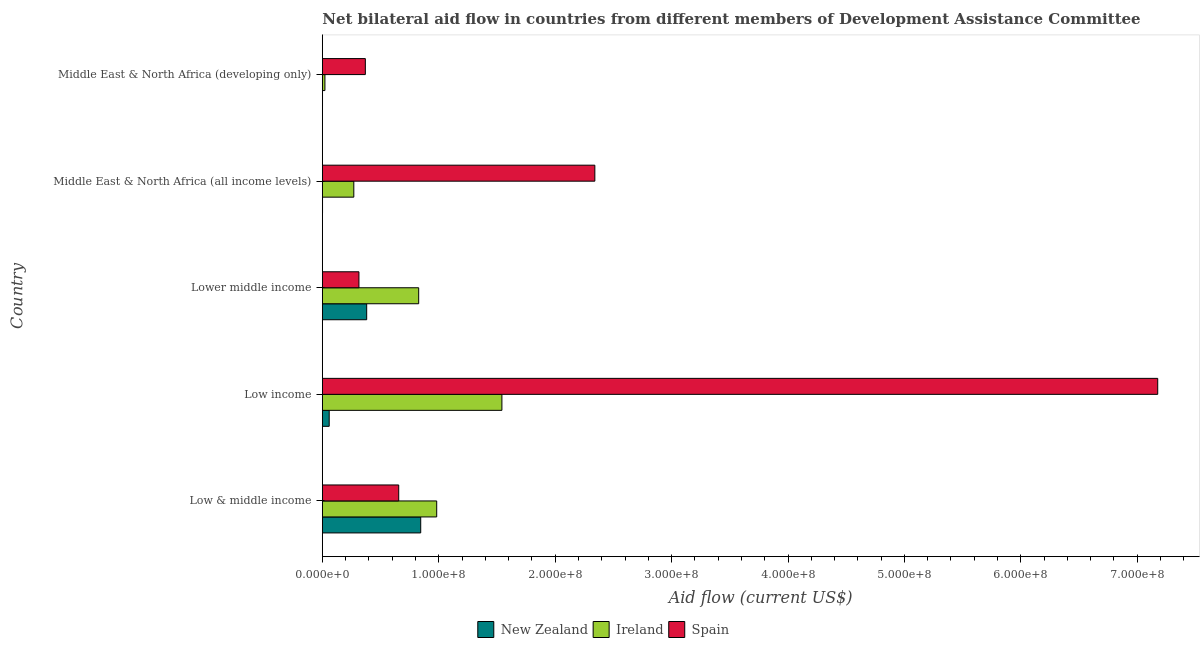How many groups of bars are there?
Your response must be concise. 5. Are the number of bars per tick equal to the number of legend labels?
Provide a short and direct response. Yes. Are the number of bars on each tick of the Y-axis equal?
Offer a terse response. Yes. What is the label of the 5th group of bars from the top?
Offer a very short reply. Low & middle income. In how many cases, is the number of bars for a given country not equal to the number of legend labels?
Offer a very short reply. 0. What is the amount of aid provided by ireland in Middle East & North Africa (developing only)?
Keep it short and to the point. 2.23e+06. Across all countries, what is the maximum amount of aid provided by new zealand?
Offer a terse response. 8.45e+07. Across all countries, what is the minimum amount of aid provided by new zealand?
Ensure brevity in your answer.  1.60e+05. In which country was the amount of aid provided by spain minimum?
Your response must be concise. Lower middle income. What is the total amount of aid provided by new zealand in the graph?
Provide a succinct answer. 1.29e+08. What is the difference between the amount of aid provided by ireland in Low income and that in Middle East & North Africa (developing only)?
Provide a short and direct response. 1.52e+08. What is the difference between the amount of aid provided by spain in Low & middle income and the amount of aid provided by new zealand in Low income?
Provide a succinct answer. 5.97e+07. What is the average amount of aid provided by ireland per country?
Ensure brevity in your answer.  7.29e+07. What is the difference between the amount of aid provided by new zealand and amount of aid provided by spain in Middle East & North Africa (all income levels)?
Offer a very short reply. -2.34e+08. What is the ratio of the amount of aid provided by spain in Lower middle income to that in Middle East & North Africa (developing only)?
Keep it short and to the point. 0.85. Is the amount of aid provided by new zealand in Low & middle income less than that in Lower middle income?
Your answer should be compact. No. Is the difference between the amount of aid provided by new zealand in Low income and Middle East & North Africa (developing only) greater than the difference between the amount of aid provided by spain in Low income and Middle East & North Africa (developing only)?
Ensure brevity in your answer.  No. What is the difference between the highest and the second highest amount of aid provided by new zealand?
Your answer should be very brief. 4.64e+07. What is the difference between the highest and the lowest amount of aid provided by spain?
Provide a succinct answer. 6.86e+08. Is the sum of the amount of aid provided by spain in Low income and Middle East & North Africa (all income levels) greater than the maximum amount of aid provided by ireland across all countries?
Provide a short and direct response. Yes. What does the 1st bar from the top in Middle East & North Africa (developing only) represents?
Your response must be concise. Spain. What does the 1st bar from the bottom in Middle East & North Africa (all income levels) represents?
Make the answer very short. New Zealand. Are all the bars in the graph horizontal?
Your answer should be very brief. Yes. Does the graph contain any zero values?
Give a very brief answer. No. Does the graph contain grids?
Make the answer very short. No. How many legend labels are there?
Make the answer very short. 3. How are the legend labels stacked?
Your response must be concise. Horizontal. What is the title of the graph?
Make the answer very short. Net bilateral aid flow in countries from different members of Development Assistance Committee. Does "Social insurance" appear as one of the legend labels in the graph?
Your response must be concise. No. What is the label or title of the Y-axis?
Your response must be concise. Country. What is the Aid flow (current US$) in New Zealand in Low & middle income?
Your response must be concise. 8.45e+07. What is the Aid flow (current US$) of Ireland in Low & middle income?
Offer a very short reply. 9.82e+07. What is the Aid flow (current US$) in Spain in Low & middle income?
Offer a very short reply. 6.56e+07. What is the Aid flow (current US$) in New Zealand in Low income?
Provide a short and direct response. 5.90e+06. What is the Aid flow (current US$) in Ireland in Low income?
Provide a succinct answer. 1.54e+08. What is the Aid flow (current US$) of Spain in Low income?
Your response must be concise. 7.18e+08. What is the Aid flow (current US$) of New Zealand in Lower middle income?
Provide a short and direct response. 3.81e+07. What is the Aid flow (current US$) of Ireland in Lower middle income?
Ensure brevity in your answer.  8.28e+07. What is the Aid flow (current US$) of Spain in Lower middle income?
Your response must be concise. 3.14e+07. What is the Aid flow (current US$) of New Zealand in Middle East & North Africa (all income levels)?
Keep it short and to the point. 1.80e+05. What is the Aid flow (current US$) of Ireland in Middle East & North Africa (all income levels)?
Your answer should be compact. 2.70e+07. What is the Aid flow (current US$) in Spain in Middle East & North Africa (all income levels)?
Provide a succinct answer. 2.34e+08. What is the Aid flow (current US$) of Ireland in Middle East & North Africa (developing only)?
Provide a short and direct response. 2.23e+06. What is the Aid flow (current US$) in Spain in Middle East & North Africa (developing only)?
Ensure brevity in your answer.  3.70e+07. Across all countries, what is the maximum Aid flow (current US$) in New Zealand?
Your answer should be very brief. 8.45e+07. Across all countries, what is the maximum Aid flow (current US$) in Ireland?
Ensure brevity in your answer.  1.54e+08. Across all countries, what is the maximum Aid flow (current US$) in Spain?
Your answer should be very brief. 7.18e+08. Across all countries, what is the minimum Aid flow (current US$) of Ireland?
Ensure brevity in your answer.  2.23e+06. Across all countries, what is the minimum Aid flow (current US$) of Spain?
Provide a short and direct response. 3.14e+07. What is the total Aid flow (current US$) in New Zealand in the graph?
Make the answer very short. 1.29e+08. What is the total Aid flow (current US$) of Ireland in the graph?
Offer a terse response. 3.65e+08. What is the total Aid flow (current US$) of Spain in the graph?
Make the answer very short. 1.09e+09. What is the difference between the Aid flow (current US$) of New Zealand in Low & middle income and that in Low income?
Offer a very short reply. 7.86e+07. What is the difference between the Aid flow (current US$) of Ireland in Low & middle income and that in Low income?
Provide a succinct answer. -5.60e+07. What is the difference between the Aid flow (current US$) of Spain in Low & middle income and that in Low income?
Your answer should be compact. -6.52e+08. What is the difference between the Aid flow (current US$) in New Zealand in Low & middle income and that in Lower middle income?
Your answer should be compact. 4.64e+07. What is the difference between the Aid flow (current US$) in Ireland in Low & middle income and that in Lower middle income?
Provide a succinct answer. 1.55e+07. What is the difference between the Aid flow (current US$) in Spain in Low & middle income and that in Lower middle income?
Your response must be concise. 3.42e+07. What is the difference between the Aid flow (current US$) of New Zealand in Low & middle income and that in Middle East & North Africa (all income levels)?
Give a very brief answer. 8.43e+07. What is the difference between the Aid flow (current US$) in Ireland in Low & middle income and that in Middle East & North Africa (all income levels)?
Keep it short and to the point. 7.12e+07. What is the difference between the Aid flow (current US$) of Spain in Low & middle income and that in Middle East & North Africa (all income levels)?
Offer a very short reply. -1.68e+08. What is the difference between the Aid flow (current US$) in New Zealand in Low & middle income and that in Middle East & North Africa (developing only)?
Make the answer very short. 8.44e+07. What is the difference between the Aid flow (current US$) of Ireland in Low & middle income and that in Middle East & North Africa (developing only)?
Give a very brief answer. 9.60e+07. What is the difference between the Aid flow (current US$) of Spain in Low & middle income and that in Middle East & North Africa (developing only)?
Provide a succinct answer. 2.87e+07. What is the difference between the Aid flow (current US$) of New Zealand in Low income and that in Lower middle income?
Your response must be concise. -3.22e+07. What is the difference between the Aid flow (current US$) of Ireland in Low income and that in Lower middle income?
Offer a very short reply. 7.15e+07. What is the difference between the Aid flow (current US$) in Spain in Low income and that in Lower middle income?
Make the answer very short. 6.86e+08. What is the difference between the Aid flow (current US$) of New Zealand in Low income and that in Middle East & North Africa (all income levels)?
Your answer should be very brief. 5.72e+06. What is the difference between the Aid flow (current US$) in Ireland in Low income and that in Middle East & North Africa (all income levels)?
Provide a succinct answer. 1.27e+08. What is the difference between the Aid flow (current US$) of Spain in Low income and that in Middle East & North Africa (all income levels)?
Keep it short and to the point. 4.84e+08. What is the difference between the Aid flow (current US$) of New Zealand in Low income and that in Middle East & North Africa (developing only)?
Provide a short and direct response. 5.74e+06. What is the difference between the Aid flow (current US$) of Ireland in Low income and that in Middle East & North Africa (developing only)?
Offer a terse response. 1.52e+08. What is the difference between the Aid flow (current US$) of Spain in Low income and that in Middle East & North Africa (developing only)?
Provide a succinct answer. 6.81e+08. What is the difference between the Aid flow (current US$) of New Zealand in Lower middle income and that in Middle East & North Africa (all income levels)?
Make the answer very short. 3.79e+07. What is the difference between the Aid flow (current US$) in Ireland in Lower middle income and that in Middle East & North Africa (all income levels)?
Offer a terse response. 5.57e+07. What is the difference between the Aid flow (current US$) of Spain in Lower middle income and that in Middle East & North Africa (all income levels)?
Your answer should be very brief. -2.03e+08. What is the difference between the Aid flow (current US$) of New Zealand in Lower middle income and that in Middle East & North Africa (developing only)?
Ensure brevity in your answer.  3.79e+07. What is the difference between the Aid flow (current US$) of Ireland in Lower middle income and that in Middle East & North Africa (developing only)?
Provide a succinct answer. 8.05e+07. What is the difference between the Aid flow (current US$) in Spain in Lower middle income and that in Middle East & North Africa (developing only)?
Ensure brevity in your answer.  -5.50e+06. What is the difference between the Aid flow (current US$) in Ireland in Middle East & North Africa (all income levels) and that in Middle East & North Africa (developing only)?
Make the answer very short. 2.48e+07. What is the difference between the Aid flow (current US$) in Spain in Middle East & North Africa (all income levels) and that in Middle East & North Africa (developing only)?
Make the answer very short. 1.97e+08. What is the difference between the Aid flow (current US$) in New Zealand in Low & middle income and the Aid flow (current US$) in Ireland in Low income?
Provide a succinct answer. -6.97e+07. What is the difference between the Aid flow (current US$) of New Zealand in Low & middle income and the Aid flow (current US$) of Spain in Low income?
Your answer should be very brief. -6.33e+08. What is the difference between the Aid flow (current US$) in Ireland in Low & middle income and the Aid flow (current US$) in Spain in Low income?
Offer a terse response. -6.19e+08. What is the difference between the Aid flow (current US$) in New Zealand in Low & middle income and the Aid flow (current US$) in Ireland in Lower middle income?
Your answer should be compact. 1.74e+06. What is the difference between the Aid flow (current US$) of New Zealand in Low & middle income and the Aid flow (current US$) of Spain in Lower middle income?
Offer a very short reply. 5.31e+07. What is the difference between the Aid flow (current US$) of Ireland in Low & middle income and the Aid flow (current US$) of Spain in Lower middle income?
Your response must be concise. 6.68e+07. What is the difference between the Aid flow (current US$) in New Zealand in Low & middle income and the Aid flow (current US$) in Ireland in Middle East & North Africa (all income levels)?
Offer a terse response. 5.75e+07. What is the difference between the Aid flow (current US$) in New Zealand in Low & middle income and the Aid flow (current US$) in Spain in Middle East & North Africa (all income levels)?
Ensure brevity in your answer.  -1.50e+08. What is the difference between the Aid flow (current US$) of Ireland in Low & middle income and the Aid flow (current US$) of Spain in Middle East & North Africa (all income levels)?
Give a very brief answer. -1.36e+08. What is the difference between the Aid flow (current US$) in New Zealand in Low & middle income and the Aid flow (current US$) in Ireland in Middle East & North Africa (developing only)?
Provide a succinct answer. 8.23e+07. What is the difference between the Aid flow (current US$) of New Zealand in Low & middle income and the Aid flow (current US$) of Spain in Middle East & North Africa (developing only)?
Your answer should be very brief. 4.76e+07. What is the difference between the Aid flow (current US$) of Ireland in Low & middle income and the Aid flow (current US$) of Spain in Middle East & North Africa (developing only)?
Offer a very short reply. 6.13e+07. What is the difference between the Aid flow (current US$) in New Zealand in Low income and the Aid flow (current US$) in Ireland in Lower middle income?
Offer a terse response. -7.69e+07. What is the difference between the Aid flow (current US$) in New Zealand in Low income and the Aid flow (current US$) in Spain in Lower middle income?
Keep it short and to the point. -2.56e+07. What is the difference between the Aid flow (current US$) in Ireland in Low income and the Aid flow (current US$) in Spain in Lower middle income?
Provide a short and direct response. 1.23e+08. What is the difference between the Aid flow (current US$) of New Zealand in Low income and the Aid flow (current US$) of Ireland in Middle East & North Africa (all income levels)?
Give a very brief answer. -2.11e+07. What is the difference between the Aid flow (current US$) in New Zealand in Low income and the Aid flow (current US$) in Spain in Middle East & North Africa (all income levels)?
Your response must be concise. -2.28e+08. What is the difference between the Aid flow (current US$) in Ireland in Low income and the Aid flow (current US$) in Spain in Middle East & North Africa (all income levels)?
Your response must be concise. -7.98e+07. What is the difference between the Aid flow (current US$) of New Zealand in Low income and the Aid flow (current US$) of Ireland in Middle East & North Africa (developing only)?
Give a very brief answer. 3.67e+06. What is the difference between the Aid flow (current US$) in New Zealand in Low income and the Aid flow (current US$) in Spain in Middle East & North Africa (developing only)?
Provide a succinct answer. -3.10e+07. What is the difference between the Aid flow (current US$) of Ireland in Low income and the Aid flow (current US$) of Spain in Middle East & North Africa (developing only)?
Offer a very short reply. 1.17e+08. What is the difference between the Aid flow (current US$) in New Zealand in Lower middle income and the Aid flow (current US$) in Ireland in Middle East & North Africa (all income levels)?
Make the answer very short. 1.11e+07. What is the difference between the Aid flow (current US$) in New Zealand in Lower middle income and the Aid flow (current US$) in Spain in Middle East & North Africa (all income levels)?
Your response must be concise. -1.96e+08. What is the difference between the Aid flow (current US$) of Ireland in Lower middle income and the Aid flow (current US$) of Spain in Middle East & North Africa (all income levels)?
Make the answer very short. -1.51e+08. What is the difference between the Aid flow (current US$) in New Zealand in Lower middle income and the Aid flow (current US$) in Ireland in Middle East & North Africa (developing only)?
Give a very brief answer. 3.59e+07. What is the difference between the Aid flow (current US$) in New Zealand in Lower middle income and the Aid flow (current US$) in Spain in Middle East & North Africa (developing only)?
Your answer should be very brief. 1.15e+06. What is the difference between the Aid flow (current US$) in Ireland in Lower middle income and the Aid flow (current US$) in Spain in Middle East & North Africa (developing only)?
Your response must be concise. 4.58e+07. What is the difference between the Aid flow (current US$) in New Zealand in Middle East & North Africa (all income levels) and the Aid flow (current US$) in Ireland in Middle East & North Africa (developing only)?
Your response must be concise. -2.05e+06. What is the difference between the Aid flow (current US$) in New Zealand in Middle East & North Africa (all income levels) and the Aid flow (current US$) in Spain in Middle East & North Africa (developing only)?
Offer a terse response. -3.68e+07. What is the difference between the Aid flow (current US$) in Ireland in Middle East & North Africa (all income levels) and the Aid flow (current US$) in Spain in Middle East & North Africa (developing only)?
Your answer should be compact. -9.91e+06. What is the average Aid flow (current US$) in New Zealand per country?
Ensure brevity in your answer.  2.58e+07. What is the average Aid flow (current US$) in Ireland per country?
Ensure brevity in your answer.  7.29e+07. What is the average Aid flow (current US$) of Spain per country?
Give a very brief answer. 2.17e+08. What is the difference between the Aid flow (current US$) in New Zealand and Aid flow (current US$) in Ireland in Low & middle income?
Offer a terse response. -1.37e+07. What is the difference between the Aid flow (current US$) of New Zealand and Aid flow (current US$) of Spain in Low & middle income?
Your answer should be compact. 1.89e+07. What is the difference between the Aid flow (current US$) of Ireland and Aid flow (current US$) of Spain in Low & middle income?
Your answer should be compact. 3.26e+07. What is the difference between the Aid flow (current US$) of New Zealand and Aid flow (current US$) of Ireland in Low income?
Offer a terse response. -1.48e+08. What is the difference between the Aid flow (current US$) of New Zealand and Aid flow (current US$) of Spain in Low income?
Keep it short and to the point. -7.12e+08. What is the difference between the Aid flow (current US$) of Ireland and Aid flow (current US$) of Spain in Low income?
Keep it short and to the point. -5.63e+08. What is the difference between the Aid flow (current US$) in New Zealand and Aid flow (current US$) in Ireland in Lower middle income?
Offer a very short reply. -4.47e+07. What is the difference between the Aid flow (current US$) in New Zealand and Aid flow (current US$) in Spain in Lower middle income?
Give a very brief answer. 6.65e+06. What is the difference between the Aid flow (current US$) of Ireland and Aid flow (current US$) of Spain in Lower middle income?
Make the answer very short. 5.13e+07. What is the difference between the Aid flow (current US$) of New Zealand and Aid flow (current US$) of Ireland in Middle East & North Africa (all income levels)?
Offer a very short reply. -2.69e+07. What is the difference between the Aid flow (current US$) in New Zealand and Aid flow (current US$) in Spain in Middle East & North Africa (all income levels)?
Your answer should be compact. -2.34e+08. What is the difference between the Aid flow (current US$) in Ireland and Aid flow (current US$) in Spain in Middle East & North Africa (all income levels)?
Your answer should be compact. -2.07e+08. What is the difference between the Aid flow (current US$) of New Zealand and Aid flow (current US$) of Ireland in Middle East & North Africa (developing only)?
Give a very brief answer. -2.07e+06. What is the difference between the Aid flow (current US$) of New Zealand and Aid flow (current US$) of Spain in Middle East & North Africa (developing only)?
Ensure brevity in your answer.  -3.68e+07. What is the difference between the Aid flow (current US$) of Ireland and Aid flow (current US$) of Spain in Middle East & North Africa (developing only)?
Offer a terse response. -3.47e+07. What is the ratio of the Aid flow (current US$) in New Zealand in Low & middle income to that in Low income?
Offer a terse response. 14.32. What is the ratio of the Aid flow (current US$) of Ireland in Low & middle income to that in Low income?
Your answer should be compact. 0.64. What is the ratio of the Aid flow (current US$) of Spain in Low & middle income to that in Low income?
Ensure brevity in your answer.  0.09. What is the ratio of the Aid flow (current US$) in New Zealand in Low & middle income to that in Lower middle income?
Ensure brevity in your answer.  2.22. What is the ratio of the Aid flow (current US$) of Ireland in Low & middle income to that in Lower middle income?
Your answer should be very brief. 1.19. What is the ratio of the Aid flow (current US$) in Spain in Low & middle income to that in Lower middle income?
Provide a short and direct response. 2.09. What is the ratio of the Aid flow (current US$) of New Zealand in Low & middle income to that in Middle East & North Africa (all income levels)?
Your answer should be very brief. 469.5. What is the ratio of the Aid flow (current US$) in Ireland in Low & middle income to that in Middle East & North Africa (all income levels)?
Ensure brevity in your answer.  3.63. What is the ratio of the Aid flow (current US$) in Spain in Low & middle income to that in Middle East & North Africa (all income levels)?
Ensure brevity in your answer.  0.28. What is the ratio of the Aid flow (current US$) in New Zealand in Low & middle income to that in Middle East & North Africa (developing only)?
Make the answer very short. 528.19. What is the ratio of the Aid flow (current US$) of Ireland in Low & middle income to that in Middle East & North Africa (developing only)?
Ensure brevity in your answer.  44.06. What is the ratio of the Aid flow (current US$) in Spain in Low & middle income to that in Middle East & North Africa (developing only)?
Provide a short and direct response. 1.78. What is the ratio of the Aid flow (current US$) of New Zealand in Low income to that in Lower middle income?
Offer a terse response. 0.15. What is the ratio of the Aid flow (current US$) in Ireland in Low income to that in Lower middle income?
Provide a succinct answer. 1.86. What is the ratio of the Aid flow (current US$) of Spain in Low income to that in Lower middle income?
Provide a succinct answer. 22.82. What is the ratio of the Aid flow (current US$) in New Zealand in Low income to that in Middle East & North Africa (all income levels)?
Ensure brevity in your answer.  32.78. What is the ratio of the Aid flow (current US$) in Ireland in Low income to that in Middle East & North Africa (all income levels)?
Provide a succinct answer. 5.7. What is the ratio of the Aid flow (current US$) of Spain in Low income to that in Middle East & North Africa (all income levels)?
Provide a succinct answer. 3.07. What is the ratio of the Aid flow (current US$) of New Zealand in Low income to that in Middle East & North Africa (developing only)?
Provide a short and direct response. 36.88. What is the ratio of the Aid flow (current US$) of Ireland in Low income to that in Middle East & North Africa (developing only)?
Ensure brevity in your answer.  69.17. What is the ratio of the Aid flow (current US$) of Spain in Low income to that in Middle East & North Africa (developing only)?
Offer a very short reply. 19.42. What is the ratio of the Aid flow (current US$) of New Zealand in Lower middle income to that in Middle East & North Africa (all income levels)?
Your answer should be very brief. 211.67. What is the ratio of the Aid flow (current US$) in Ireland in Lower middle income to that in Middle East & North Africa (all income levels)?
Offer a very short reply. 3.06. What is the ratio of the Aid flow (current US$) in Spain in Lower middle income to that in Middle East & North Africa (all income levels)?
Your response must be concise. 0.13. What is the ratio of the Aid flow (current US$) in New Zealand in Lower middle income to that in Middle East & North Africa (developing only)?
Offer a terse response. 238.12. What is the ratio of the Aid flow (current US$) in Ireland in Lower middle income to that in Middle East & North Africa (developing only)?
Make the answer very short. 37.12. What is the ratio of the Aid flow (current US$) of Spain in Lower middle income to that in Middle East & North Africa (developing only)?
Offer a very short reply. 0.85. What is the ratio of the Aid flow (current US$) of New Zealand in Middle East & North Africa (all income levels) to that in Middle East & North Africa (developing only)?
Ensure brevity in your answer.  1.12. What is the ratio of the Aid flow (current US$) of Ireland in Middle East & North Africa (all income levels) to that in Middle East & North Africa (developing only)?
Your answer should be compact. 12.13. What is the ratio of the Aid flow (current US$) of Spain in Middle East & North Africa (all income levels) to that in Middle East & North Africa (developing only)?
Your answer should be very brief. 6.33. What is the difference between the highest and the second highest Aid flow (current US$) of New Zealand?
Make the answer very short. 4.64e+07. What is the difference between the highest and the second highest Aid flow (current US$) in Ireland?
Give a very brief answer. 5.60e+07. What is the difference between the highest and the second highest Aid flow (current US$) of Spain?
Your response must be concise. 4.84e+08. What is the difference between the highest and the lowest Aid flow (current US$) in New Zealand?
Your answer should be very brief. 8.44e+07. What is the difference between the highest and the lowest Aid flow (current US$) of Ireland?
Make the answer very short. 1.52e+08. What is the difference between the highest and the lowest Aid flow (current US$) in Spain?
Give a very brief answer. 6.86e+08. 